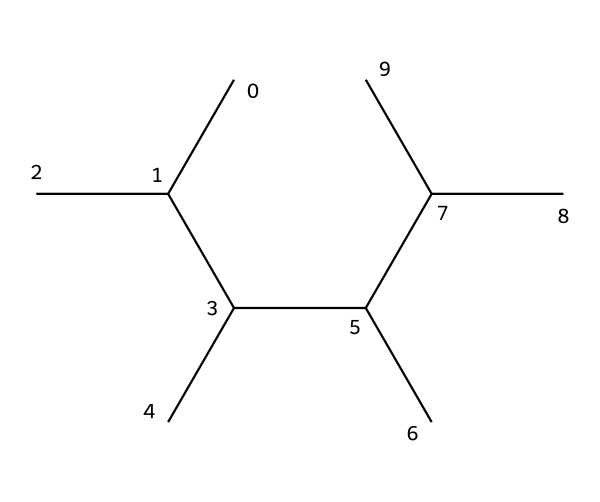What is the number of carbon atoms in this chemical structure? The provided SMILES indicates a chain of carbon atoms where each 'C' represents a carbon atom. By counting the individual 'C' characters in the structure, we see there are 12 carbon atoms.
Answer: 12 How many hydrogen atoms are present in this compound? With aliphatic hydrocarbons, each carbon typically bonds with enough hydrogen atoms to satisfy its tetravalency. In this case, each terminal carbon has three hydrogens and the internal carbons have two. Totaling the hydrogens gives 24.
Answer: 24 What type of bonding predominates in this polyethylene structure? The SMILES structure shows all single bonds between carbon atoms, which are typical in saturated aliphatic compounds. Thus, the predominant bonding in polyethylene is single covalent bonds.
Answer: single covalent bonds What category of aliphatic compound is represented by this SMILES? This structure represents a saturated hydrocarbon due to the absence of double or triple bonds. It belongs to the category of aliphatic compounds known as alkanes.
Answer: alkane What is the degree of saturation of this compound? Alkanes, including this one, are fully saturated as they contain only single bonds with the maximum number of hydrogen atoms relative to the number of carbon atoms. Therefore, the degree of saturation is maximum.
Answer: maximum How do the branches in this structure affect its physical properties? The presence of branches generally lowers the boiling point due to reduced surface area for intermolecular van der Waals forces, which impacts the physical state. The branched structure may also lead to lower viscosity compared to linear forms.
Answer: lowers boiling point What is the primary use of polyethylene in cricket ball coatings? Polyethylene is primarily used for its durability and weather resistance in coatings to enhance the ball's longevity and performance on different pitches.
Answer: durability 